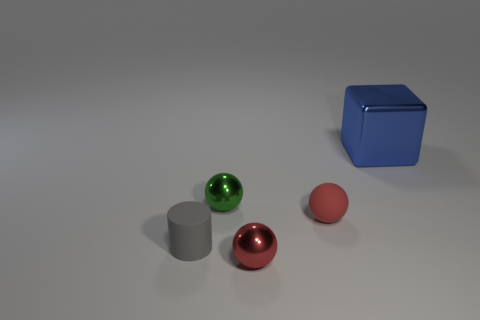What number of red metallic balls have the same size as the green thing?
Give a very brief answer. 1. The metallic block has what color?
Keep it short and to the point. Blue. There is a small cylinder; is its color the same as the small metallic thing that is to the right of the tiny green metal thing?
Provide a short and direct response. No. There is a red thing that is the same material as the tiny gray thing; what size is it?
Offer a very short reply. Small. Are there any matte cylinders that have the same color as the cube?
Ensure brevity in your answer.  No. What number of objects are either tiny objects that are right of the tiny rubber cylinder or shiny balls?
Give a very brief answer. 3. Is the blue object made of the same material as the sphere behind the tiny rubber ball?
Give a very brief answer. Yes. There is a object that is the same color as the tiny matte ball; what is its size?
Offer a terse response. Small. Is there a green ball that has the same material as the small green thing?
Make the answer very short. No. What number of objects are shiny objects in front of the big blue cube or metallic objects that are on the left side of the big blue cube?
Offer a very short reply. 2. 